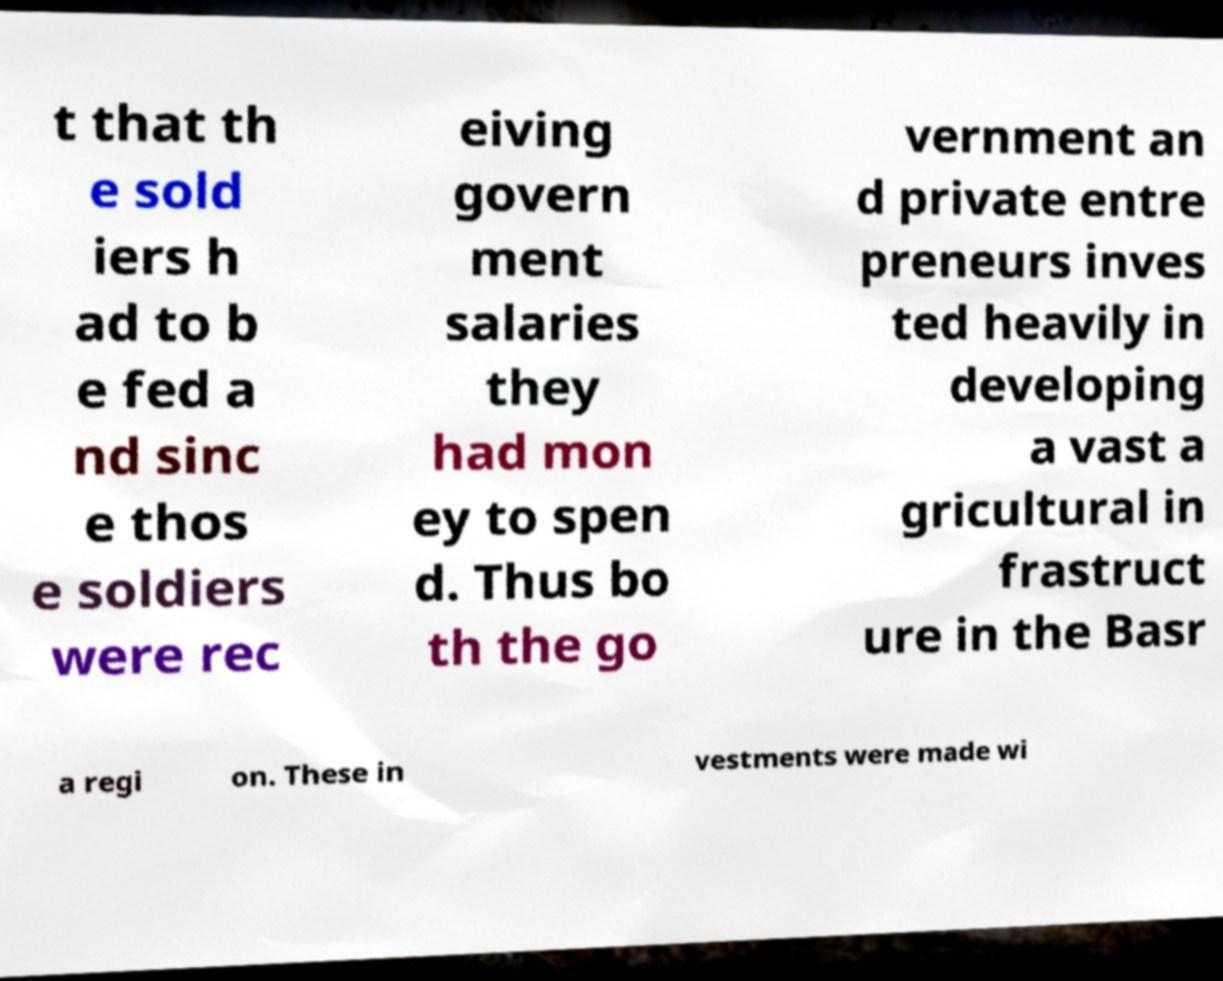Could you assist in decoding the text presented in this image and type it out clearly? t that th e sold iers h ad to b e fed a nd sinc e thos e soldiers were rec eiving govern ment salaries they had mon ey to spen d. Thus bo th the go vernment an d private entre preneurs inves ted heavily in developing a vast a gricultural in frastruct ure in the Basr a regi on. These in vestments were made wi 